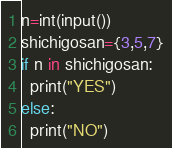<code> <loc_0><loc_0><loc_500><loc_500><_Python_>n=int(input())
shichigosan={3,5,7}
if n in shichigosan:
  print("YES")
else:
  print("NO")</code> 